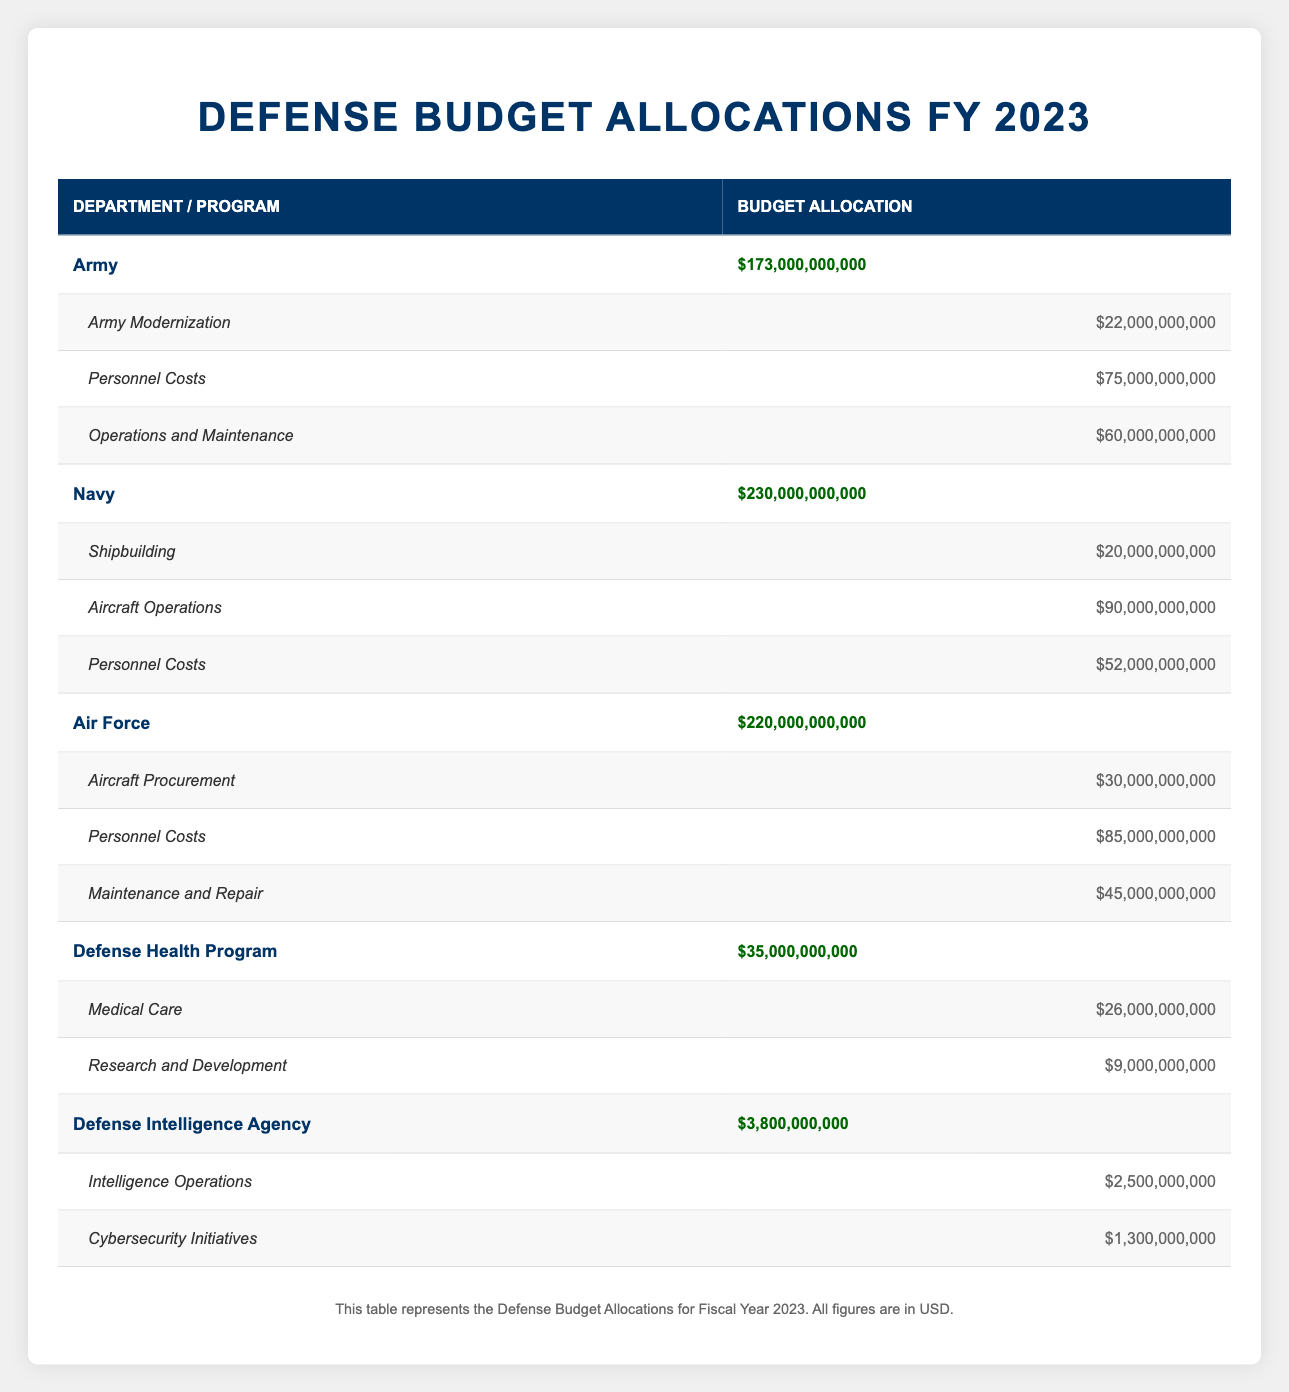What is the total defense budget allocation for the Army? The Army's total budget allocation is explicitly stated as $173,000,000,000 in the table.
Answer: $173,000,000,000 How much is allocated for Personnel Costs in the Navy? In the table, the Personnel Costs under the Navy department is listed as $52,000,000,000.
Answer: $52,000,000,000 Is the total budget allocation for the Air Force greater than that of the Navy? The total budget for the Air Force is $220,000,000,000 and for the Navy, it is $230,000,000,000. Since $220 billion is less than $230 billion, the statement is false.
Answer: No What is the combined budget allocation for the Army Modernization and Operations and Maintenance? The budget for Army Modernization is $22,000,000,000 and for Operations and Maintenance, it is $60,000,000,000. Adding these together gives $22 billion + $60 billion = $82 billion.
Answer: $82,000,000,000 What percentage of the total defense budget is allocated to the Defense Health Program? The total defense budget is the sum of all department allocations: $173 billion + $230 billion + $220 billion + $35 billion + $3.8 billion = $662.8 billion. The Defense Health Program's allocation is $35 billion. To find the percentage, (35 billion / 662.8 billion) * 100 = approximately 5.28%.
Answer: 5.28% What is the budget allocation for Aircraft Procurement compared to Shipbuilding? Aircraft Procurement has a budget allocation of $30,000,000,000, while Shipbuilding is allocated $20,000,000,000. The difference is $30 billion - $20 billion = $10 billion, indicating that Aircraft Procurement has a larger allocation.
Answer: Aircraft Procurement is $10 billion more than Shipbuilding Which department has the least budget allocation? The table shows that the Defense Intelligence Agency has the smallest allocation of $3,800,000,000.
Answer: Defense Intelligence Agency If the Navy received an additional $10 billion, what would its new total allocation be? The current Navy allocation is $230,000,000,000. Adding $10 billion gives $230 billion + $10 billion = $240 billion.
Answer: $240,000,000,000 